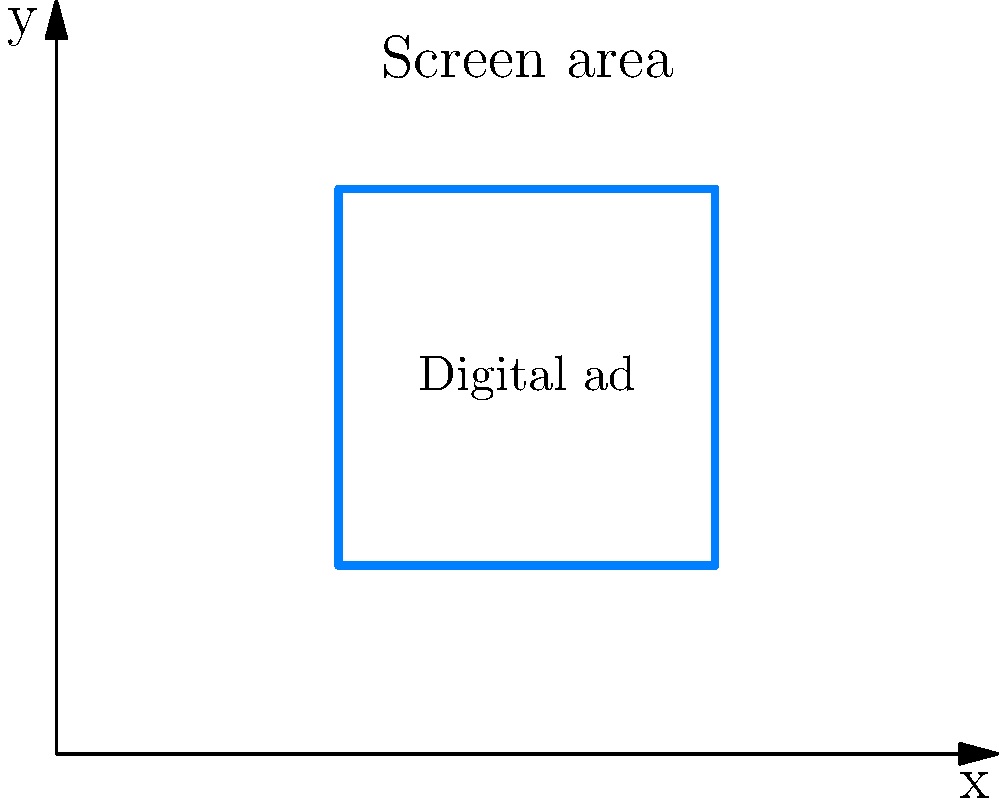As a digital media promoter, you're tasked with optimizing the placement of a rectangular digital ad on a website. The website's viewable area is represented by a coordinate plane where each unit represents 100 pixels. The optimal ad position is determined to be a rectangle with corners at (3,2), (7,2), (7,6), and (3,6). What is the area of the digital ad in square pixels, and what percentage of the total viewable area (assuming the viewable area is 1000x800 pixels) does it occupy? Let's approach this step-by-step:

1. Calculate the dimensions of the ad:
   Width = 7 - 3 = 4 units
   Height = 6 - 2 = 4 units

2. Convert units to pixels:
   Width in pixels = 4 * 100 = 400 pixels
   Height in pixels = 4 * 100 = 400 pixels

3. Calculate the area of the ad:
   Area = Width * Height = 400 * 400 = 160,000 square pixels

4. Calculate the total viewable area:
   Total area = 1000 * 800 = 800,000 square pixels

5. Calculate the percentage of the viewable area occupied by the ad:
   Percentage = (Ad area / Total area) * 100
              = (160,000 / 800,000) * 100
              = 0.2 * 100 = 20%

Therefore, the digital ad occupies an area of 160,000 square pixels, which is 20% of the total viewable area.
Answer: 160,000 square pixels; 20% of viewable area 